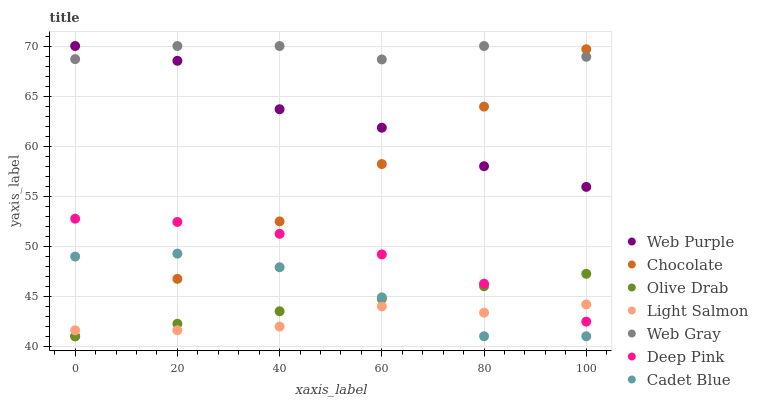Does Light Salmon have the minimum area under the curve?
Answer yes or no. Yes. Does Web Gray have the maximum area under the curve?
Answer yes or no. Yes. Does Deep Pink have the minimum area under the curve?
Answer yes or no. No. Does Deep Pink have the maximum area under the curve?
Answer yes or no. No. Is Chocolate the smoothest?
Answer yes or no. Yes. Is Web Purple the roughest?
Answer yes or no. Yes. Is Deep Pink the smoothest?
Answer yes or no. No. Is Deep Pink the roughest?
Answer yes or no. No. Does Cadet Blue have the lowest value?
Answer yes or no. Yes. Does Deep Pink have the lowest value?
Answer yes or no. No. Does Web Gray have the highest value?
Answer yes or no. Yes. Does Deep Pink have the highest value?
Answer yes or no. No. Is Olive Drab less than Web Purple?
Answer yes or no. Yes. Is Deep Pink greater than Cadet Blue?
Answer yes or no. Yes. Does Cadet Blue intersect Light Salmon?
Answer yes or no. Yes. Is Cadet Blue less than Light Salmon?
Answer yes or no. No. Is Cadet Blue greater than Light Salmon?
Answer yes or no. No. Does Olive Drab intersect Web Purple?
Answer yes or no. No. 